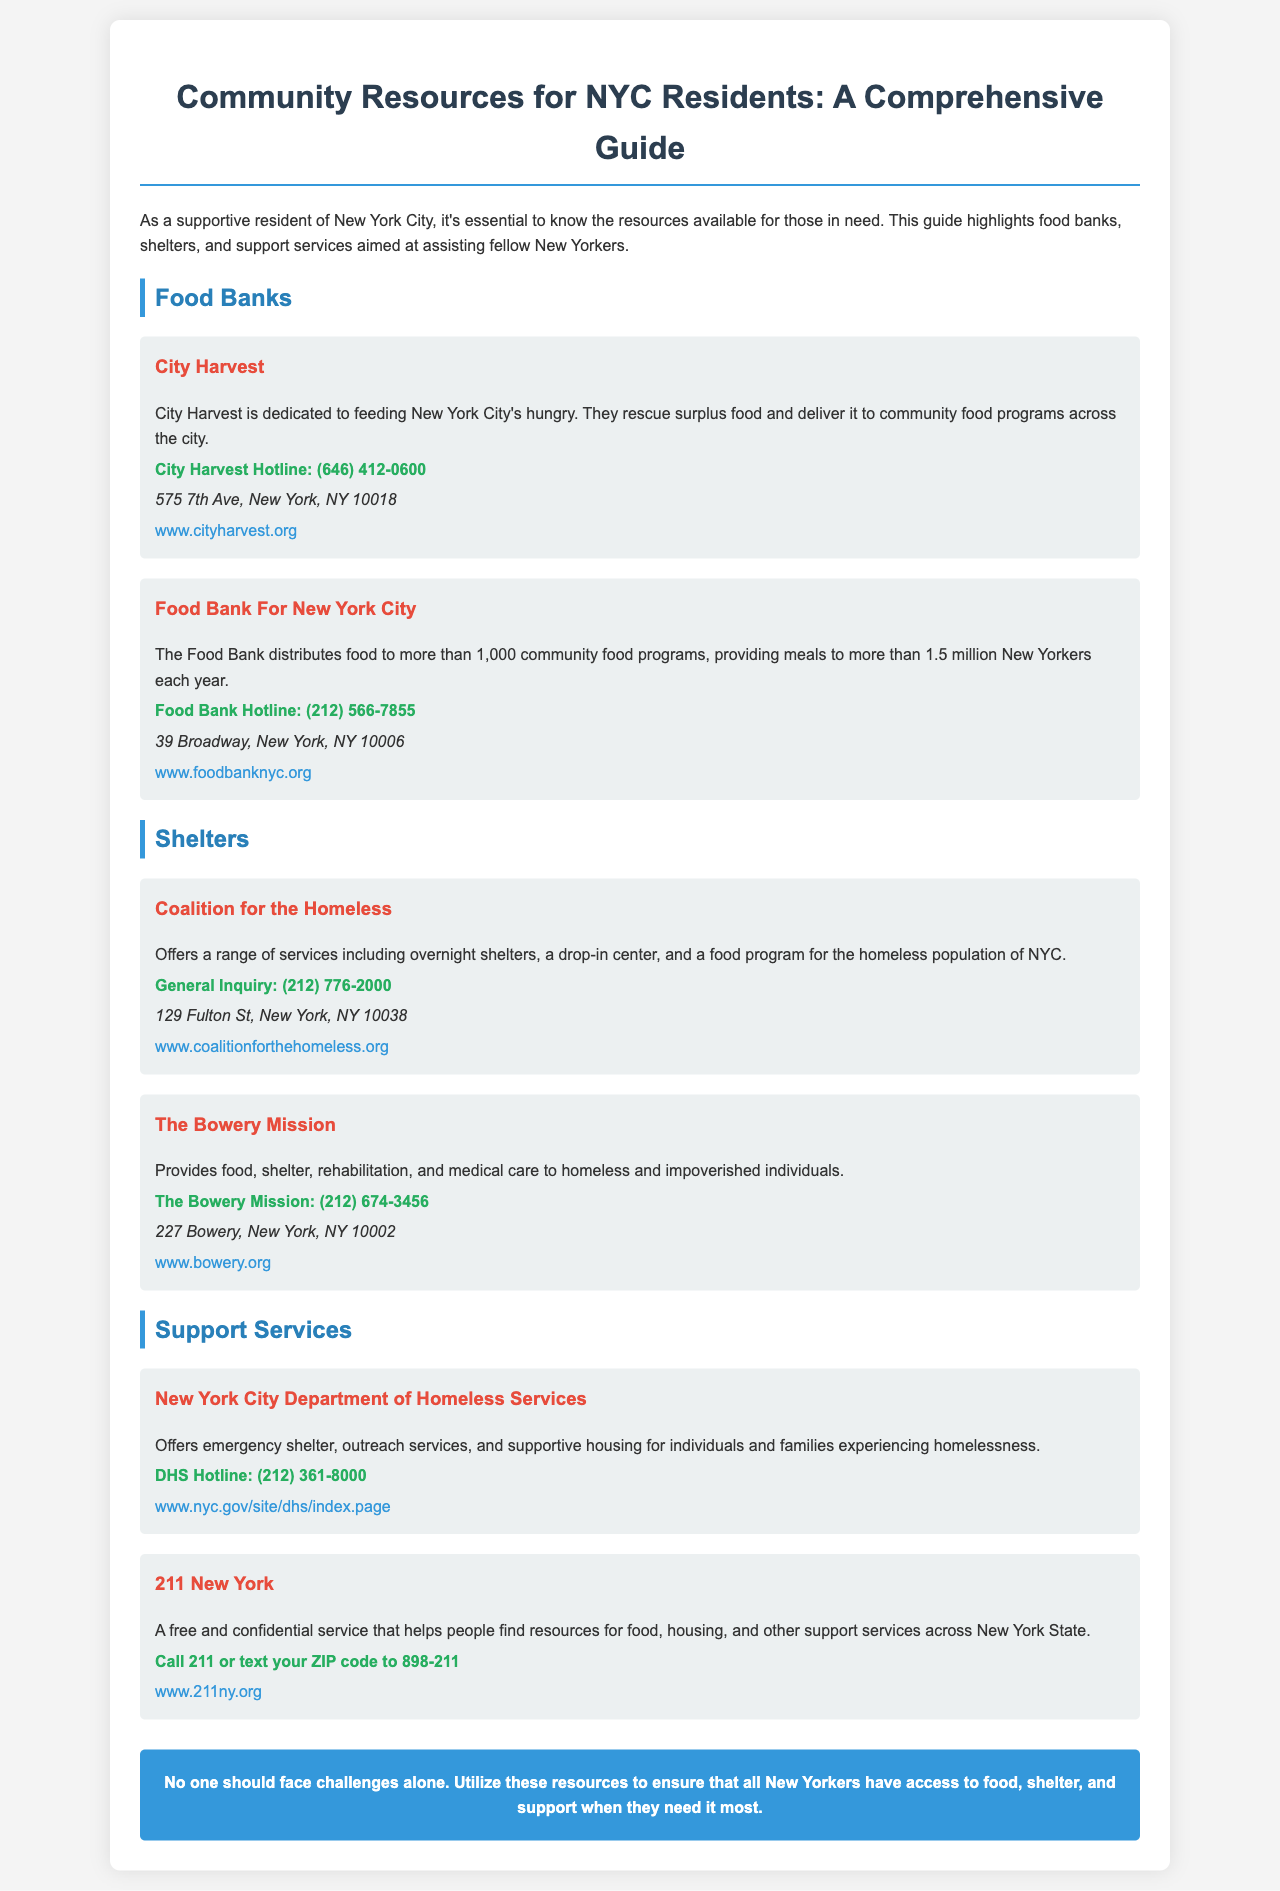What is the contact number for City Harvest? The document lists the hotline for City Harvest, which is (646) 412-0600.
Answer: (646) 412-0600 How many New Yorkers does the Food Bank serve each year? The Food Bank provides meals to more than 1.5 million New Yorkers each year, according to the document.
Answer: More than 1.5 million What services does the Coalition for the Homeless provide? The document states that the Coalition for the Homeless offers overnight shelters, a drop-in center, and a food program.
Answer: Overnight shelters, drop-in center, food program What is the address of The Bowery Mission? The Bowery Mission's address is provided in the document as 227 Bowery, New York, NY 10002.
Answer: 227 Bowery, New York, NY 10002 What number do you call for 211 New York services? The document mentions to call 211 for 211 New York services.
Answer: 211 What is the website for the New York City Department of Homeless Services? The website for the New York City Department of Homeless Services is included in the document as www.nyc.gov/site/dhs/index.page.
Answer: www.nyc.gov/site/dhs/index.page What type of resource is City Harvest? The document categorizes City Harvest as a food bank.
Answer: Food bank What is the primary mission of City Harvest? The primary mission stated in the document is to feed New York City's hungry by rescuing surplus food.
Answer: Feeding New York City's hungry How can one text for 211 New York assistance? According to the document, one can text their ZIP code to 898-211 for assistance.
Answer: Text ZIP code to 898-211 